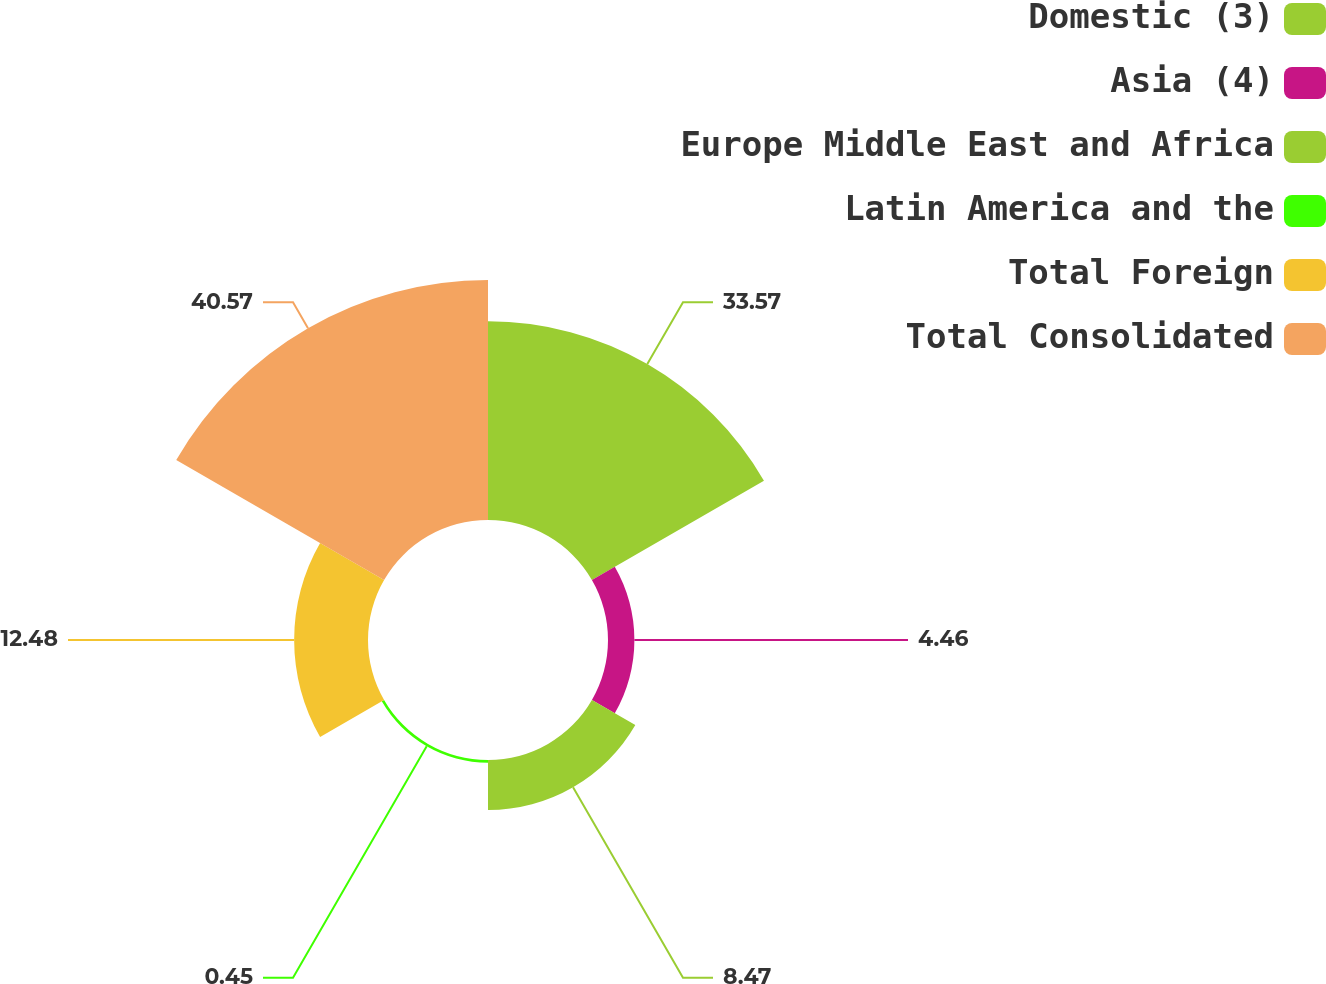Convert chart to OTSL. <chart><loc_0><loc_0><loc_500><loc_500><pie_chart><fcel>Domestic (3)<fcel>Asia (4)<fcel>Europe Middle East and Africa<fcel>Latin America and the<fcel>Total Foreign<fcel>Total Consolidated<nl><fcel>33.57%<fcel>4.46%<fcel>8.47%<fcel>0.45%<fcel>12.48%<fcel>40.56%<nl></chart> 